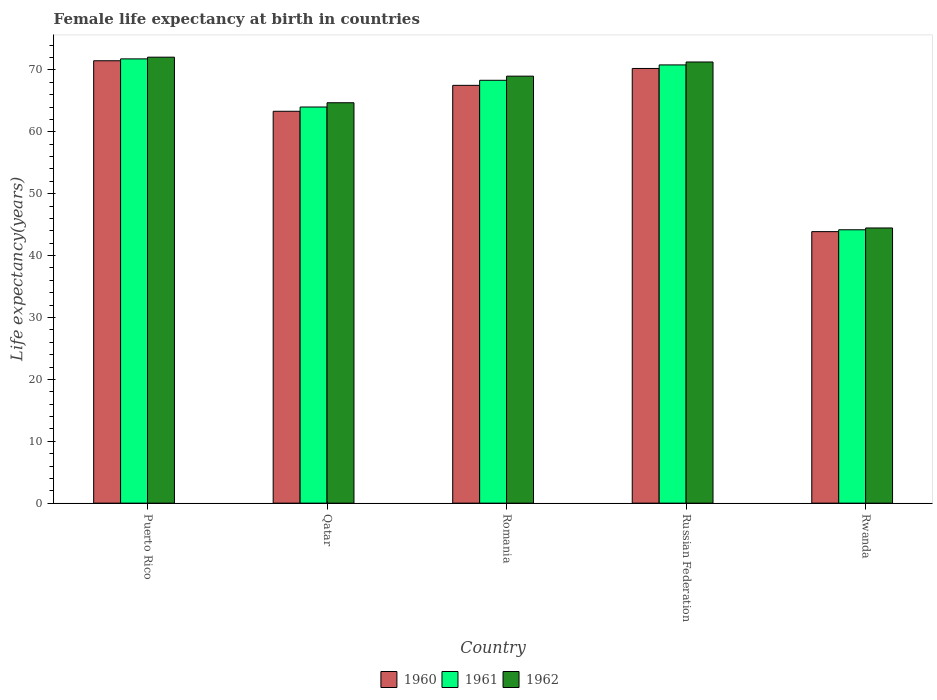How many different coloured bars are there?
Offer a terse response. 3. How many groups of bars are there?
Your answer should be compact. 5. Are the number of bars per tick equal to the number of legend labels?
Offer a terse response. Yes. Are the number of bars on each tick of the X-axis equal?
Offer a very short reply. Yes. How many bars are there on the 2nd tick from the left?
Provide a short and direct response. 3. How many bars are there on the 1st tick from the right?
Ensure brevity in your answer.  3. What is the label of the 5th group of bars from the left?
Keep it short and to the point. Rwanda. What is the female life expectancy at birth in 1962 in Qatar?
Provide a succinct answer. 64.7. Across all countries, what is the maximum female life expectancy at birth in 1962?
Offer a very short reply. 72.07. Across all countries, what is the minimum female life expectancy at birth in 1962?
Offer a terse response. 44.47. In which country was the female life expectancy at birth in 1961 maximum?
Provide a succinct answer. Puerto Rico. In which country was the female life expectancy at birth in 1960 minimum?
Your answer should be compact. Rwanda. What is the total female life expectancy at birth in 1961 in the graph?
Keep it short and to the point. 319.13. What is the difference between the female life expectancy at birth in 1962 in Puerto Rico and that in Romania?
Provide a succinct answer. 3.07. What is the difference between the female life expectancy at birth in 1961 in Romania and the female life expectancy at birth in 1962 in Rwanda?
Keep it short and to the point. 23.86. What is the average female life expectancy at birth in 1960 per country?
Provide a short and direct response. 63.29. What is the difference between the female life expectancy at birth of/in 1960 and female life expectancy at birth of/in 1962 in Romania?
Offer a terse response. -1.49. What is the ratio of the female life expectancy at birth in 1962 in Qatar to that in Romania?
Offer a terse response. 0.94. What is the difference between the highest and the second highest female life expectancy at birth in 1962?
Make the answer very short. 3.07. What is the difference between the highest and the lowest female life expectancy at birth in 1961?
Keep it short and to the point. 27.62. In how many countries, is the female life expectancy at birth in 1960 greater than the average female life expectancy at birth in 1960 taken over all countries?
Your response must be concise. 4. Is the sum of the female life expectancy at birth in 1962 in Romania and Russian Federation greater than the maximum female life expectancy at birth in 1961 across all countries?
Give a very brief answer. Yes. Is it the case that in every country, the sum of the female life expectancy at birth in 1960 and female life expectancy at birth in 1961 is greater than the female life expectancy at birth in 1962?
Give a very brief answer. Yes. How many countries are there in the graph?
Keep it short and to the point. 5. What is the difference between two consecutive major ticks on the Y-axis?
Provide a succinct answer. 10. Are the values on the major ticks of Y-axis written in scientific E-notation?
Provide a short and direct response. No. How are the legend labels stacked?
Your answer should be very brief. Horizontal. What is the title of the graph?
Ensure brevity in your answer.  Female life expectancy at birth in countries. What is the label or title of the Y-axis?
Your answer should be very brief. Life expectancy(years). What is the Life expectancy(years) of 1960 in Puerto Rico?
Your answer should be very brief. 71.49. What is the Life expectancy(years) in 1961 in Puerto Rico?
Give a very brief answer. 71.79. What is the Life expectancy(years) in 1962 in Puerto Rico?
Your answer should be compact. 72.07. What is the Life expectancy(years) of 1960 in Qatar?
Give a very brief answer. 63.32. What is the Life expectancy(years) of 1961 in Qatar?
Make the answer very short. 64.01. What is the Life expectancy(years) in 1962 in Qatar?
Provide a short and direct response. 64.7. What is the Life expectancy(years) in 1960 in Romania?
Your answer should be very brief. 67.51. What is the Life expectancy(years) of 1961 in Romania?
Your answer should be compact. 68.33. What is the Life expectancy(years) of 1960 in Russian Federation?
Provide a succinct answer. 70.24. What is the Life expectancy(years) of 1961 in Russian Federation?
Offer a very short reply. 70.82. What is the Life expectancy(years) in 1962 in Russian Federation?
Your answer should be compact. 71.29. What is the Life expectancy(years) in 1960 in Rwanda?
Offer a terse response. 43.88. What is the Life expectancy(years) of 1961 in Rwanda?
Offer a terse response. 44.18. What is the Life expectancy(years) in 1962 in Rwanda?
Provide a succinct answer. 44.47. Across all countries, what is the maximum Life expectancy(years) in 1960?
Provide a succinct answer. 71.49. Across all countries, what is the maximum Life expectancy(years) in 1961?
Offer a terse response. 71.79. Across all countries, what is the maximum Life expectancy(years) in 1962?
Your answer should be compact. 72.07. Across all countries, what is the minimum Life expectancy(years) in 1960?
Ensure brevity in your answer.  43.88. Across all countries, what is the minimum Life expectancy(years) in 1961?
Provide a short and direct response. 44.18. Across all countries, what is the minimum Life expectancy(years) of 1962?
Your response must be concise. 44.47. What is the total Life expectancy(years) of 1960 in the graph?
Keep it short and to the point. 316.44. What is the total Life expectancy(years) in 1961 in the graph?
Ensure brevity in your answer.  319.13. What is the total Life expectancy(years) of 1962 in the graph?
Offer a very short reply. 321.52. What is the difference between the Life expectancy(years) of 1960 in Puerto Rico and that in Qatar?
Offer a very short reply. 8.16. What is the difference between the Life expectancy(years) of 1961 in Puerto Rico and that in Qatar?
Offer a terse response. 7.78. What is the difference between the Life expectancy(years) in 1962 in Puerto Rico and that in Qatar?
Provide a short and direct response. 7.36. What is the difference between the Life expectancy(years) of 1960 in Puerto Rico and that in Romania?
Your answer should be compact. 3.97. What is the difference between the Life expectancy(years) of 1961 in Puerto Rico and that in Romania?
Ensure brevity in your answer.  3.46. What is the difference between the Life expectancy(years) of 1962 in Puerto Rico and that in Romania?
Ensure brevity in your answer.  3.07. What is the difference between the Life expectancy(years) in 1960 in Puerto Rico and that in Russian Federation?
Your answer should be compact. 1.24. What is the difference between the Life expectancy(years) of 1962 in Puerto Rico and that in Russian Federation?
Give a very brief answer. 0.78. What is the difference between the Life expectancy(years) in 1960 in Puerto Rico and that in Rwanda?
Your answer should be compact. 27.61. What is the difference between the Life expectancy(years) of 1961 in Puerto Rico and that in Rwanda?
Make the answer very short. 27.62. What is the difference between the Life expectancy(years) of 1962 in Puerto Rico and that in Rwanda?
Give a very brief answer. 27.6. What is the difference between the Life expectancy(years) of 1960 in Qatar and that in Romania?
Give a very brief answer. -4.19. What is the difference between the Life expectancy(years) in 1961 in Qatar and that in Romania?
Provide a short and direct response. -4.32. What is the difference between the Life expectancy(years) in 1962 in Qatar and that in Romania?
Provide a succinct answer. -4.3. What is the difference between the Life expectancy(years) of 1960 in Qatar and that in Russian Federation?
Offer a very short reply. -6.92. What is the difference between the Life expectancy(years) in 1961 in Qatar and that in Russian Federation?
Keep it short and to the point. -6.8. What is the difference between the Life expectancy(years) of 1962 in Qatar and that in Russian Federation?
Keep it short and to the point. -6.58. What is the difference between the Life expectancy(years) of 1960 in Qatar and that in Rwanda?
Provide a short and direct response. 19.45. What is the difference between the Life expectancy(years) of 1961 in Qatar and that in Rwanda?
Offer a very short reply. 19.84. What is the difference between the Life expectancy(years) of 1962 in Qatar and that in Rwanda?
Your response must be concise. 20.24. What is the difference between the Life expectancy(years) of 1960 in Romania and that in Russian Federation?
Keep it short and to the point. -2.73. What is the difference between the Life expectancy(years) in 1961 in Romania and that in Russian Federation?
Your response must be concise. -2.48. What is the difference between the Life expectancy(years) of 1962 in Romania and that in Russian Federation?
Keep it short and to the point. -2.29. What is the difference between the Life expectancy(years) of 1960 in Romania and that in Rwanda?
Give a very brief answer. 23.64. What is the difference between the Life expectancy(years) in 1961 in Romania and that in Rwanda?
Your response must be concise. 24.16. What is the difference between the Life expectancy(years) in 1962 in Romania and that in Rwanda?
Provide a succinct answer. 24.53. What is the difference between the Life expectancy(years) of 1960 in Russian Federation and that in Rwanda?
Offer a very short reply. 26.37. What is the difference between the Life expectancy(years) of 1961 in Russian Federation and that in Rwanda?
Provide a succinct answer. 26.64. What is the difference between the Life expectancy(years) of 1962 in Russian Federation and that in Rwanda?
Offer a very short reply. 26.82. What is the difference between the Life expectancy(years) of 1960 in Puerto Rico and the Life expectancy(years) of 1961 in Qatar?
Give a very brief answer. 7.47. What is the difference between the Life expectancy(years) of 1960 in Puerto Rico and the Life expectancy(years) of 1962 in Qatar?
Your answer should be compact. 6.78. What is the difference between the Life expectancy(years) in 1961 in Puerto Rico and the Life expectancy(years) in 1962 in Qatar?
Keep it short and to the point. 7.09. What is the difference between the Life expectancy(years) in 1960 in Puerto Rico and the Life expectancy(years) in 1961 in Romania?
Provide a succinct answer. 3.15. What is the difference between the Life expectancy(years) of 1960 in Puerto Rico and the Life expectancy(years) of 1962 in Romania?
Ensure brevity in your answer.  2.49. What is the difference between the Life expectancy(years) in 1961 in Puerto Rico and the Life expectancy(years) in 1962 in Romania?
Your response must be concise. 2.79. What is the difference between the Life expectancy(years) in 1960 in Puerto Rico and the Life expectancy(years) in 1961 in Russian Federation?
Your answer should be compact. 0.67. What is the difference between the Life expectancy(years) of 1960 in Puerto Rico and the Life expectancy(years) of 1962 in Russian Federation?
Your response must be concise. 0.2. What is the difference between the Life expectancy(years) in 1961 in Puerto Rico and the Life expectancy(years) in 1962 in Russian Federation?
Provide a succinct answer. 0.5. What is the difference between the Life expectancy(years) of 1960 in Puerto Rico and the Life expectancy(years) of 1961 in Rwanda?
Provide a succinct answer. 27.31. What is the difference between the Life expectancy(years) in 1960 in Puerto Rico and the Life expectancy(years) in 1962 in Rwanda?
Offer a terse response. 27.02. What is the difference between the Life expectancy(years) in 1961 in Puerto Rico and the Life expectancy(years) in 1962 in Rwanda?
Ensure brevity in your answer.  27.32. What is the difference between the Life expectancy(years) in 1960 in Qatar and the Life expectancy(years) in 1961 in Romania?
Provide a succinct answer. -5.01. What is the difference between the Life expectancy(years) of 1960 in Qatar and the Life expectancy(years) of 1962 in Romania?
Your response must be concise. -5.68. What is the difference between the Life expectancy(years) in 1961 in Qatar and the Life expectancy(years) in 1962 in Romania?
Keep it short and to the point. -4.99. What is the difference between the Life expectancy(years) of 1960 in Qatar and the Life expectancy(years) of 1961 in Russian Federation?
Provide a short and direct response. -7.49. What is the difference between the Life expectancy(years) of 1960 in Qatar and the Life expectancy(years) of 1962 in Russian Federation?
Offer a terse response. -7.96. What is the difference between the Life expectancy(years) in 1961 in Qatar and the Life expectancy(years) in 1962 in Russian Federation?
Make the answer very short. -7.28. What is the difference between the Life expectancy(years) of 1960 in Qatar and the Life expectancy(years) of 1961 in Rwanda?
Provide a succinct answer. 19.15. What is the difference between the Life expectancy(years) in 1960 in Qatar and the Life expectancy(years) in 1962 in Rwanda?
Your answer should be very brief. 18.86. What is the difference between the Life expectancy(years) of 1961 in Qatar and the Life expectancy(years) of 1962 in Rwanda?
Your answer should be compact. 19.55. What is the difference between the Life expectancy(years) of 1960 in Romania and the Life expectancy(years) of 1961 in Russian Federation?
Provide a succinct answer. -3.3. What is the difference between the Life expectancy(years) in 1960 in Romania and the Life expectancy(years) in 1962 in Russian Federation?
Your answer should be compact. -3.77. What is the difference between the Life expectancy(years) in 1961 in Romania and the Life expectancy(years) in 1962 in Russian Federation?
Make the answer very short. -2.96. What is the difference between the Life expectancy(years) of 1960 in Romania and the Life expectancy(years) of 1961 in Rwanda?
Make the answer very short. 23.34. What is the difference between the Life expectancy(years) of 1960 in Romania and the Life expectancy(years) of 1962 in Rwanda?
Offer a terse response. 23.05. What is the difference between the Life expectancy(years) in 1961 in Romania and the Life expectancy(years) in 1962 in Rwanda?
Keep it short and to the point. 23.86. What is the difference between the Life expectancy(years) in 1960 in Russian Federation and the Life expectancy(years) in 1961 in Rwanda?
Your response must be concise. 26.07. What is the difference between the Life expectancy(years) of 1960 in Russian Federation and the Life expectancy(years) of 1962 in Rwanda?
Provide a short and direct response. 25.78. What is the difference between the Life expectancy(years) in 1961 in Russian Federation and the Life expectancy(years) in 1962 in Rwanda?
Your answer should be very brief. 26.35. What is the average Life expectancy(years) of 1960 per country?
Your response must be concise. 63.29. What is the average Life expectancy(years) in 1961 per country?
Provide a succinct answer. 63.83. What is the average Life expectancy(years) in 1962 per country?
Your response must be concise. 64.31. What is the difference between the Life expectancy(years) in 1960 and Life expectancy(years) in 1961 in Puerto Rico?
Offer a very short reply. -0.3. What is the difference between the Life expectancy(years) in 1960 and Life expectancy(years) in 1962 in Puerto Rico?
Give a very brief answer. -0.58. What is the difference between the Life expectancy(years) in 1961 and Life expectancy(years) in 1962 in Puerto Rico?
Keep it short and to the point. -0.28. What is the difference between the Life expectancy(years) in 1960 and Life expectancy(years) in 1961 in Qatar?
Make the answer very short. -0.69. What is the difference between the Life expectancy(years) in 1960 and Life expectancy(years) in 1962 in Qatar?
Ensure brevity in your answer.  -1.38. What is the difference between the Life expectancy(years) in 1961 and Life expectancy(years) in 1962 in Qatar?
Offer a very short reply. -0.69. What is the difference between the Life expectancy(years) in 1960 and Life expectancy(years) in 1961 in Romania?
Your response must be concise. -0.82. What is the difference between the Life expectancy(years) in 1960 and Life expectancy(years) in 1962 in Romania?
Your answer should be very brief. -1.49. What is the difference between the Life expectancy(years) of 1961 and Life expectancy(years) of 1962 in Romania?
Make the answer very short. -0.67. What is the difference between the Life expectancy(years) of 1960 and Life expectancy(years) of 1961 in Russian Federation?
Provide a succinct answer. -0.57. What is the difference between the Life expectancy(years) in 1960 and Life expectancy(years) in 1962 in Russian Federation?
Ensure brevity in your answer.  -1.04. What is the difference between the Life expectancy(years) of 1961 and Life expectancy(years) of 1962 in Russian Federation?
Offer a terse response. -0.47. What is the difference between the Life expectancy(years) in 1960 and Life expectancy(years) in 1961 in Rwanda?
Your answer should be compact. -0.3. What is the difference between the Life expectancy(years) of 1960 and Life expectancy(years) of 1962 in Rwanda?
Provide a succinct answer. -0.59. What is the difference between the Life expectancy(years) of 1961 and Life expectancy(years) of 1962 in Rwanda?
Your answer should be very brief. -0.29. What is the ratio of the Life expectancy(years) of 1960 in Puerto Rico to that in Qatar?
Provide a succinct answer. 1.13. What is the ratio of the Life expectancy(years) of 1961 in Puerto Rico to that in Qatar?
Offer a terse response. 1.12. What is the ratio of the Life expectancy(years) in 1962 in Puerto Rico to that in Qatar?
Make the answer very short. 1.11. What is the ratio of the Life expectancy(years) of 1960 in Puerto Rico to that in Romania?
Your answer should be very brief. 1.06. What is the ratio of the Life expectancy(years) of 1961 in Puerto Rico to that in Romania?
Provide a succinct answer. 1.05. What is the ratio of the Life expectancy(years) of 1962 in Puerto Rico to that in Romania?
Your response must be concise. 1.04. What is the ratio of the Life expectancy(years) of 1960 in Puerto Rico to that in Russian Federation?
Your answer should be very brief. 1.02. What is the ratio of the Life expectancy(years) of 1961 in Puerto Rico to that in Russian Federation?
Ensure brevity in your answer.  1.01. What is the ratio of the Life expectancy(years) of 1962 in Puerto Rico to that in Russian Federation?
Make the answer very short. 1.01. What is the ratio of the Life expectancy(years) in 1960 in Puerto Rico to that in Rwanda?
Provide a short and direct response. 1.63. What is the ratio of the Life expectancy(years) in 1961 in Puerto Rico to that in Rwanda?
Offer a terse response. 1.63. What is the ratio of the Life expectancy(years) of 1962 in Puerto Rico to that in Rwanda?
Provide a succinct answer. 1.62. What is the ratio of the Life expectancy(years) in 1960 in Qatar to that in Romania?
Offer a terse response. 0.94. What is the ratio of the Life expectancy(years) of 1961 in Qatar to that in Romania?
Make the answer very short. 0.94. What is the ratio of the Life expectancy(years) in 1962 in Qatar to that in Romania?
Make the answer very short. 0.94. What is the ratio of the Life expectancy(years) in 1960 in Qatar to that in Russian Federation?
Ensure brevity in your answer.  0.9. What is the ratio of the Life expectancy(years) of 1961 in Qatar to that in Russian Federation?
Your response must be concise. 0.9. What is the ratio of the Life expectancy(years) of 1962 in Qatar to that in Russian Federation?
Provide a succinct answer. 0.91. What is the ratio of the Life expectancy(years) of 1960 in Qatar to that in Rwanda?
Your answer should be compact. 1.44. What is the ratio of the Life expectancy(years) of 1961 in Qatar to that in Rwanda?
Provide a succinct answer. 1.45. What is the ratio of the Life expectancy(years) of 1962 in Qatar to that in Rwanda?
Provide a succinct answer. 1.46. What is the ratio of the Life expectancy(years) in 1960 in Romania to that in Russian Federation?
Ensure brevity in your answer.  0.96. What is the ratio of the Life expectancy(years) of 1961 in Romania to that in Russian Federation?
Offer a terse response. 0.96. What is the ratio of the Life expectancy(years) in 1962 in Romania to that in Russian Federation?
Keep it short and to the point. 0.97. What is the ratio of the Life expectancy(years) of 1960 in Romania to that in Rwanda?
Offer a very short reply. 1.54. What is the ratio of the Life expectancy(years) in 1961 in Romania to that in Rwanda?
Make the answer very short. 1.55. What is the ratio of the Life expectancy(years) in 1962 in Romania to that in Rwanda?
Provide a short and direct response. 1.55. What is the ratio of the Life expectancy(years) in 1960 in Russian Federation to that in Rwanda?
Offer a very short reply. 1.6. What is the ratio of the Life expectancy(years) of 1961 in Russian Federation to that in Rwanda?
Make the answer very short. 1.6. What is the ratio of the Life expectancy(years) in 1962 in Russian Federation to that in Rwanda?
Your response must be concise. 1.6. What is the difference between the highest and the second highest Life expectancy(years) of 1960?
Your answer should be very brief. 1.24. What is the difference between the highest and the second highest Life expectancy(years) of 1962?
Offer a terse response. 0.78. What is the difference between the highest and the lowest Life expectancy(years) in 1960?
Your answer should be very brief. 27.61. What is the difference between the highest and the lowest Life expectancy(years) of 1961?
Provide a short and direct response. 27.62. What is the difference between the highest and the lowest Life expectancy(years) of 1962?
Provide a succinct answer. 27.6. 